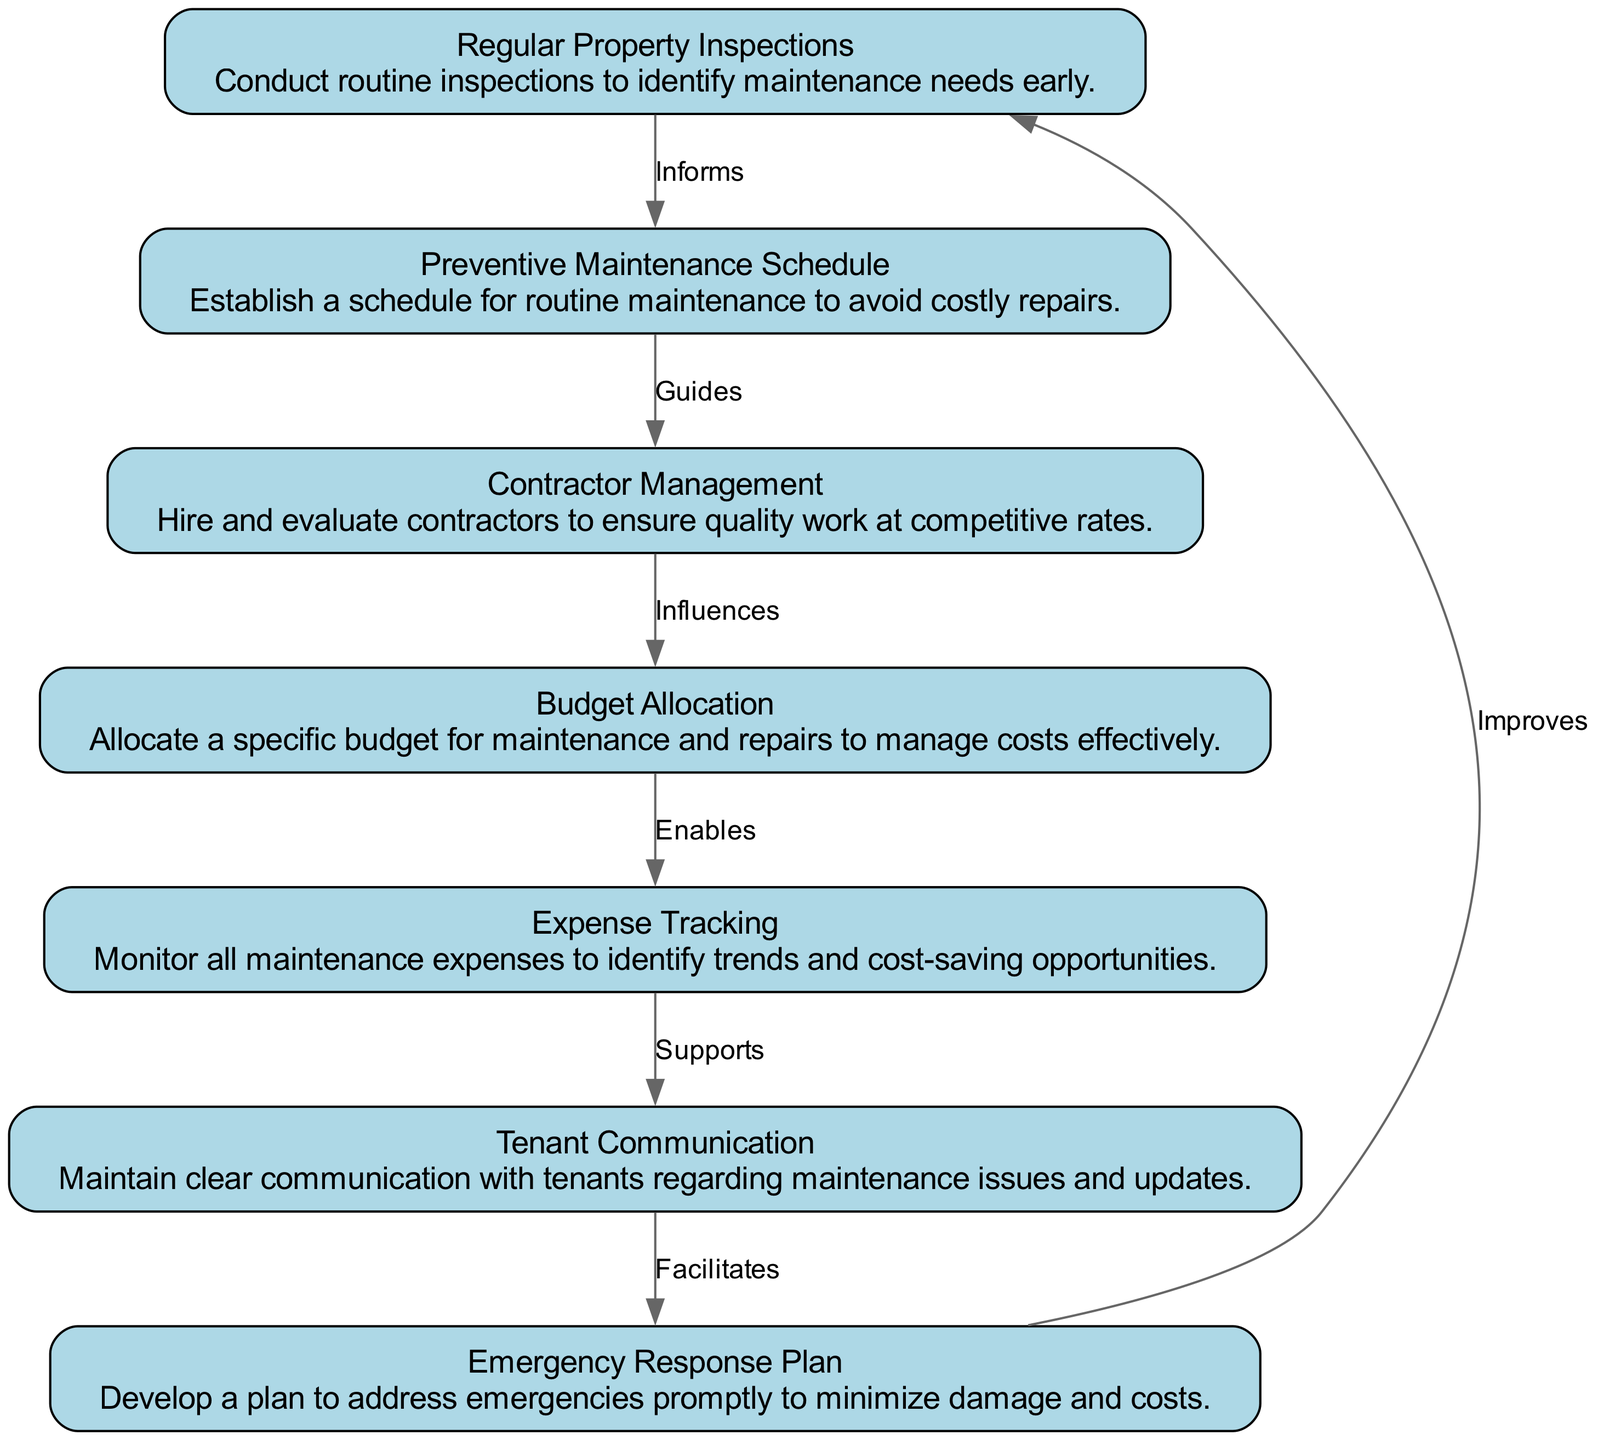What is the first step in property maintenance? The first step indicated in the flow chart is "Regular Property Inspections," which highlights the importance of conducting routine inspections to identify maintenance needs early.
Answer: Regular Property Inspections How many elements are in the flow chart? The flow chart includes a total of seven elements related to property maintenance and cost management, as detailed in the provided data.
Answer: Seven What does "Preventive Maintenance Schedule" guide? The "Preventive Maintenance Schedule" guides the process of establishing a routine for maintenance activities to avoid costly repairs, as depicted by the arrow flowing from "Regular Property Inspections" to "Preventive Maintenance Schedule."
Answer: Establishes routine Which element influences the budgeting process? "Contractor Management" influences the "Budget Allocation," suggesting that how contractors are hired and managed can affect how budgets are allocated for maintenance and repairs.
Answer: Contractor Management What supports tenant communication? The element titled "Expense Tracking" supports "Tenant Communication" by ensuring that all maintenance expenses are monitored, which potentially provides transparency to tenants about how their maintenance issues are being handled financially.
Answer: Expense Tracking What facilitates emergency response? The flow chart indicates that "Tenant Communication" facilitates the "Emergency Response Plan," indicating that clear communication with tenants is essential for effectively managing emergencies.
Answer: Tenant Communication How many relationships are there between the nodes? The diagram contains six relationships (edges) connecting the seven nodes, illustrating how each maintenance aspect is interrelated and guides subsequent actions based on preceding steps.
Answer: Six Which step improves regular inspections? The "Emergency Response Plan" improves "Regular Property Inspections," suggesting that addressing emergencies effectively can enhance future inspections by identifying areas needing attention.
Answer: Emergency Response Plan What enables effective cost management? "Budget Allocation" enables effective cost management by designating a specific budget for maintenance and repairs, ensuring that costs are managed effectively from the onset of the maintenance process.
Answer: Budget Allocation 